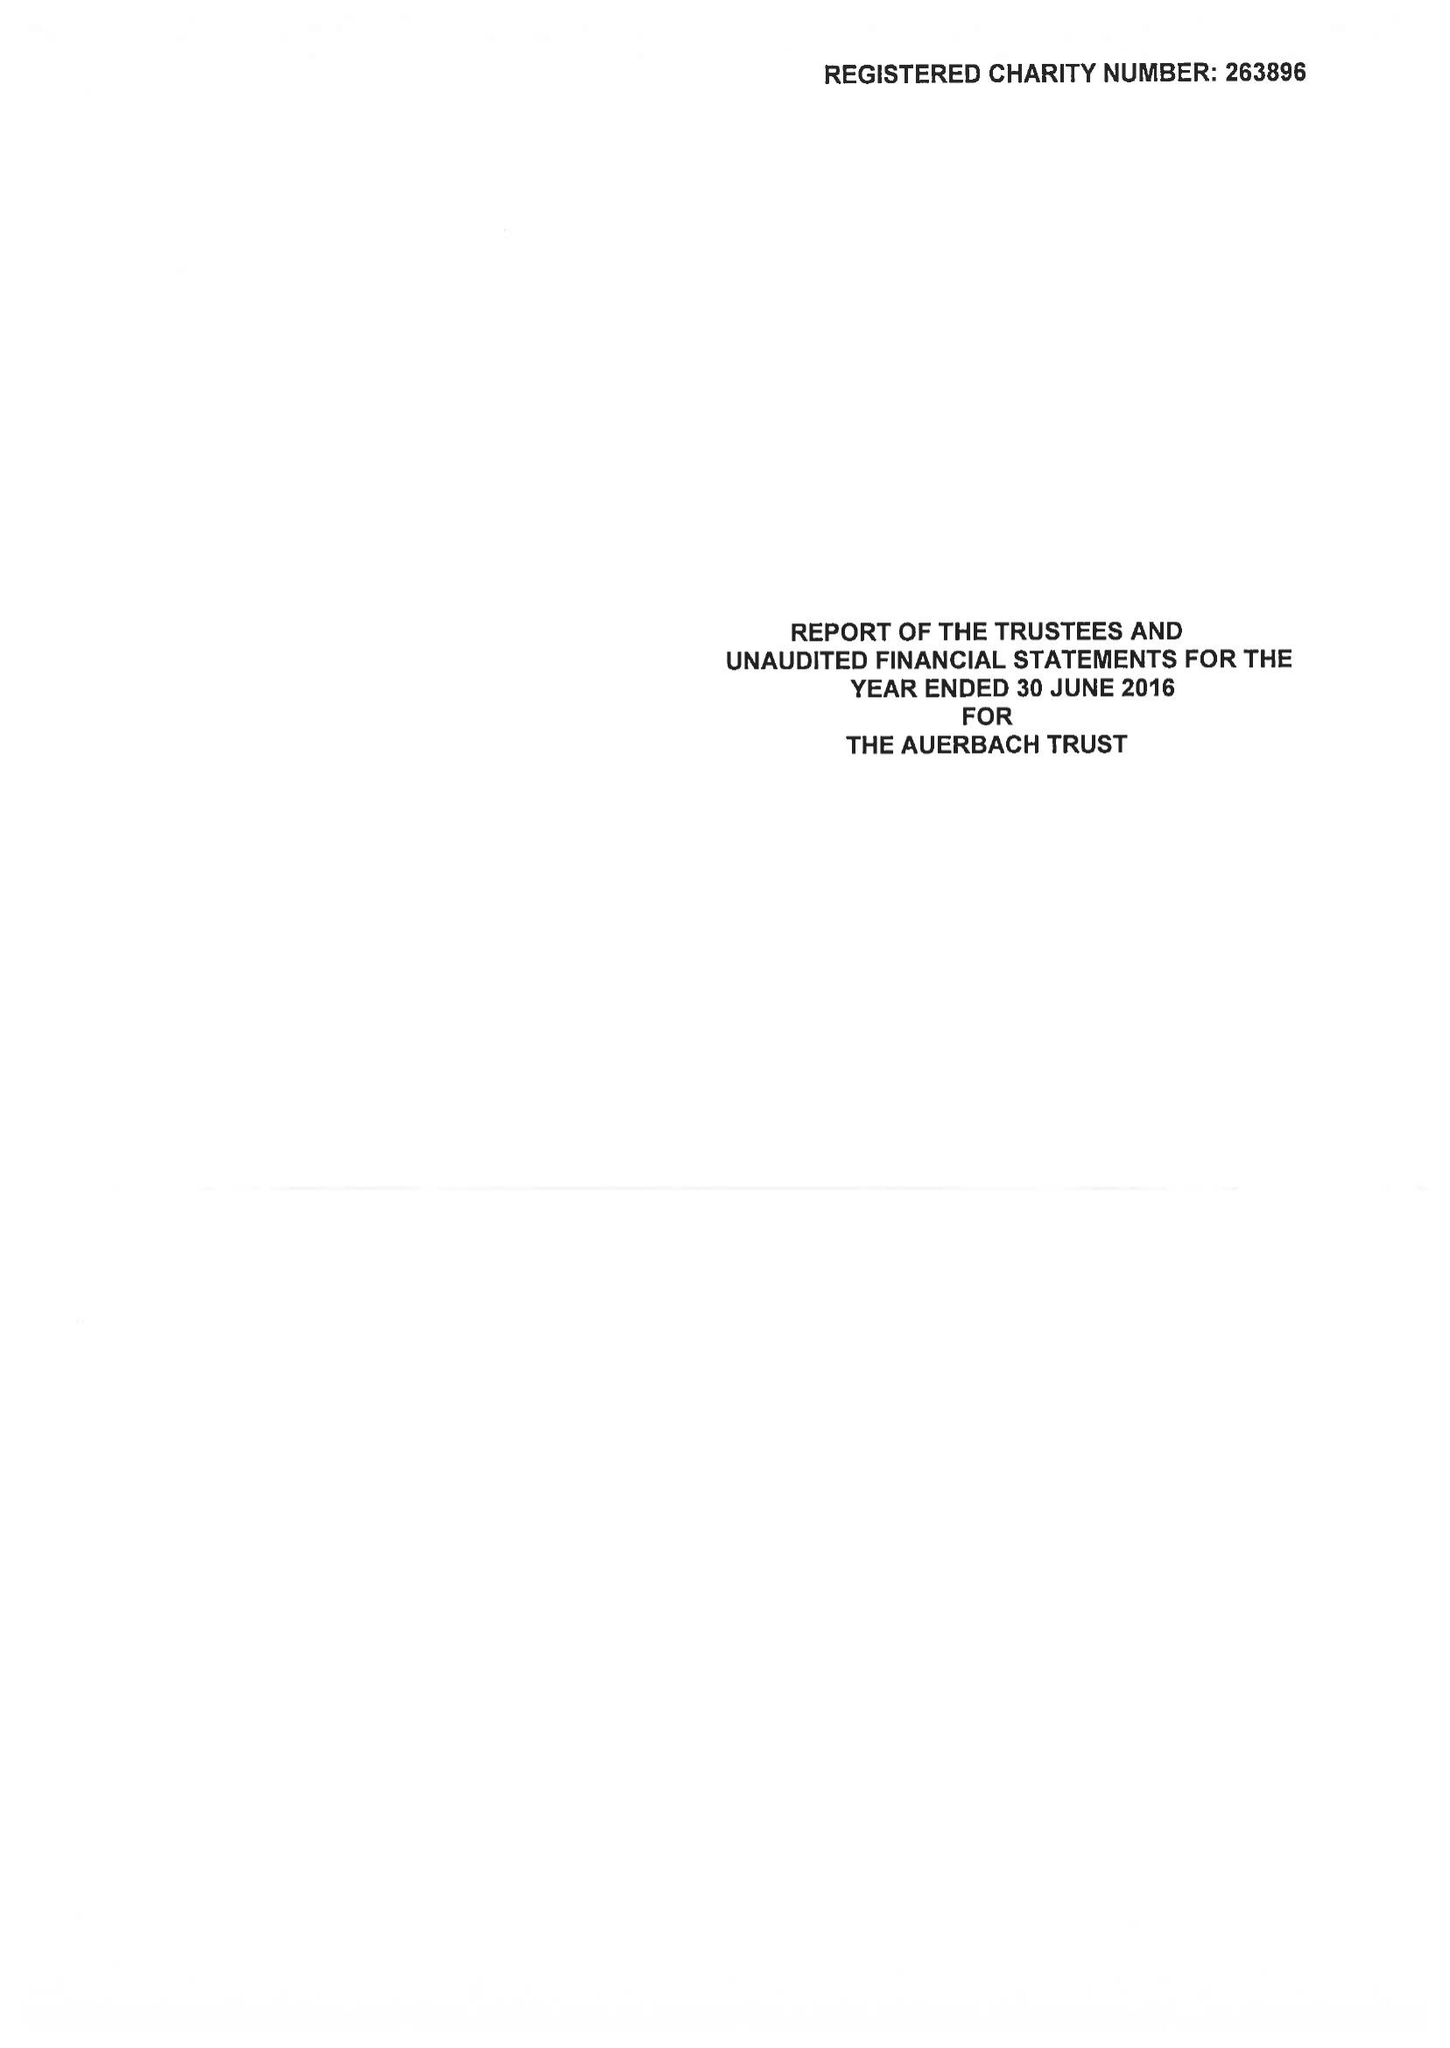What is the value for the report_date?
Answer the question using a single word or phrase. 2016-06-30 